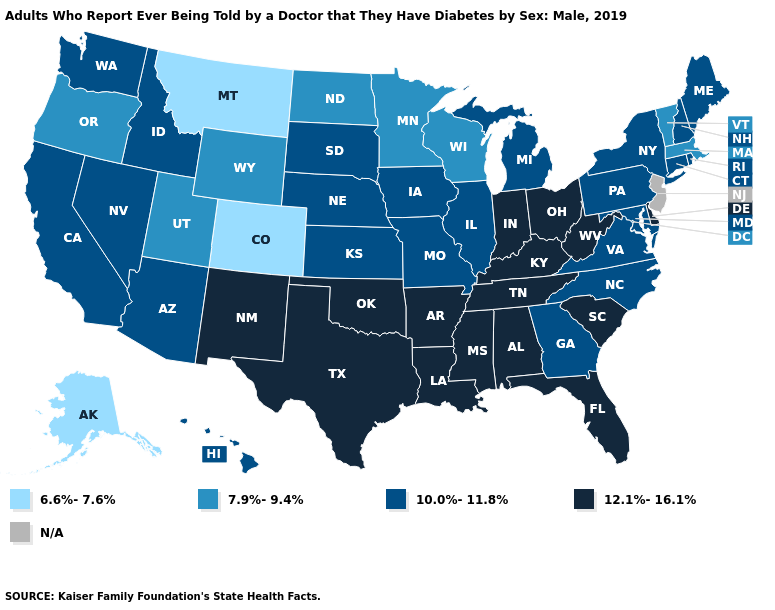Which states have the highest value in the USA?
Write a very short answer. Alabama, Arkansas, Delaware, Florida, Indiana, Kentucky, Louisiana, Mississippi, New Mexico, Ohio, Oklahoma, South Carolina, Tennessee, Texas, West Virginia. What is the value of Maine?
Quick response, please. 10.0%-11.8%. Does Rhode Island have the lowest value in the Northeast?
Concise answer only. No. How many symbols are there in the legend?
Be succinct. 5. Name the states that have a value in the range 12.1%-16.1%?
Quick response, please. Alabama, Arkansas, Delaware, Florida, Indiana, Kentucky, Louisiana, Mississippi, New Mexico, Ohio, Oklahoma, South Carolina, Tennessee, Texas, West Virginia. What is the highest value in the West ?
Write a very short answer. 12.1%-16.1%. Name the states that have a value in the range 7.9%-9.4%?
Write a very short answer. Massachusetts, Minnesota, North Dakota, Oregon, Utah, Vermont, Wisconsin, Wyoming. How many symbols are there in the legend?
Give a very brief answer. 5. Does Virginia have the highest value in the South?
Write a very short answer. No. Name the states that have a value in the range 7.9%-9.4%?
Short answer required. Massachusetts, Minnesota, North Dakota, Oregon, Utah, Vermont, Wisconsin, Wyoming. 